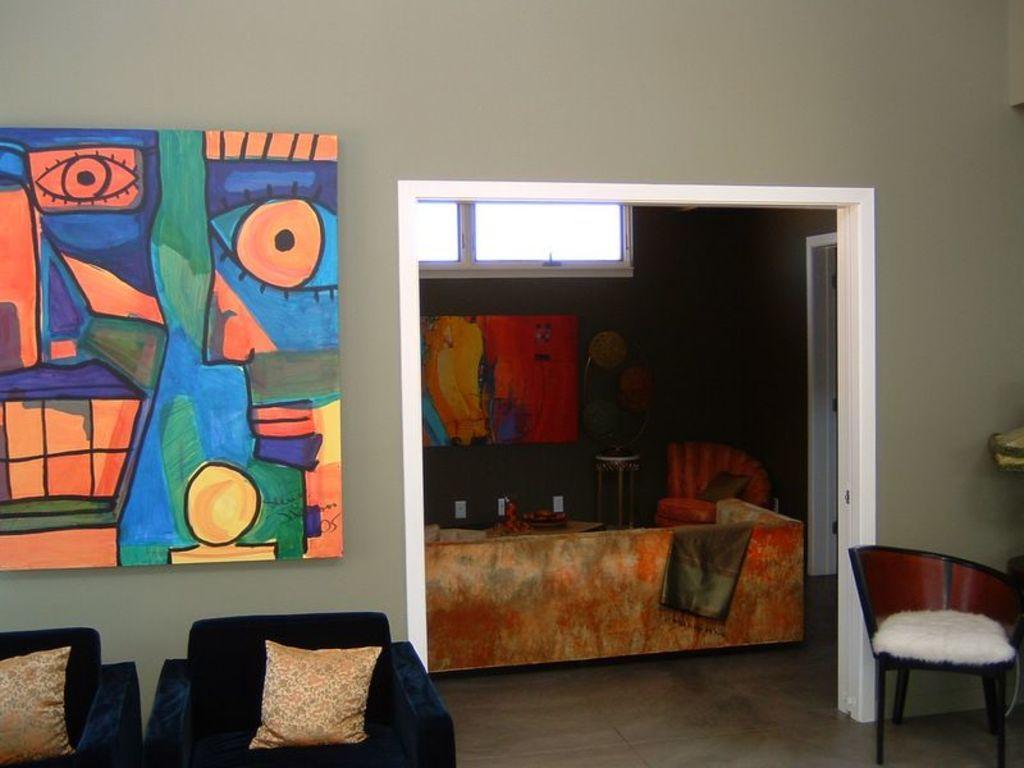Please provide a concise description of this image. In this image I can see a room with couch,chair and the board attached to the wall. 